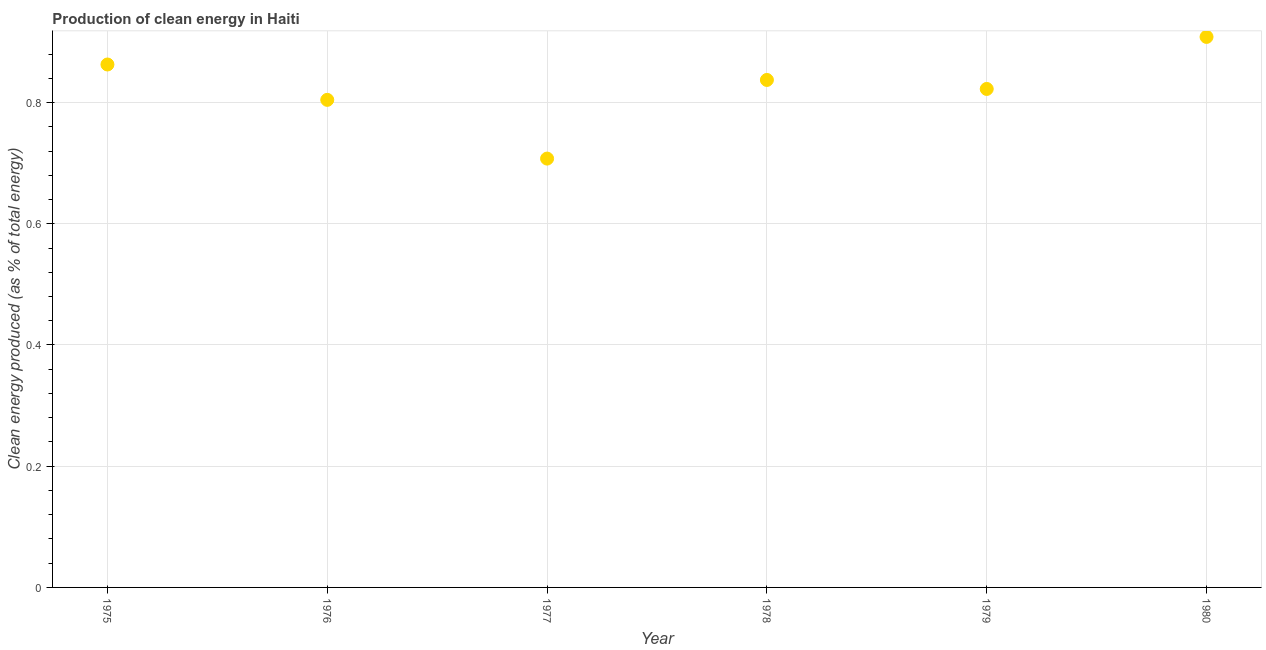What is the production of clean energy in 1977?
Offer a terse response. 0.71. Across all years, what is the maximum production of clean energy?
Offer a very short reply. 0.91. Across all years, what is the minimum production of clean energy?
Ensure brevity in your answer.  0.71. In which year was the production of clean energy minimum?
Your response must be concise. 1977. What is the sum of the production of clean energy?
Provide a short and direct response. 4.94. What is the difference between the production of clean energy in 1978 and 1980?
Ensure brevity in your answer.  -0.07. What is the average production of clean energy per year?
Ensure brevity in your answer.  0.82. What is the median production of clean energy?
Keep it short and to the point. 0.83. Do a majority of the years between 1980 and 1979 (inclusive) have production of clean energy greater than 0.32 %?
Your answer should be very brief. No. What is the ratio of the production of clean energy in 1978 to that in 1979?
Give a very brief answer. 1.02. Is the production of clean energy in 1975 less than that in 1977?
Make the answer very short. No. What is the difference between the highest and the second highest production of clean energy?
Keep it short and to the point. 0.05. What is the difference between the highest and the lowest production of clean energy?
Offer a very short reply. 0.2. In how many years, is the production of clean energy greater than the average production of clean energy taken over all years?
Give a very brief answer. 3. How many dotlines are there?
Your response must be concise. 1. How many years are there in the graph?
Make the answer very short. 6. What is the difference between two consecutive major ticks on the Y-axis?
Your answer should be very brief. 0.2. Does the graph contain grids?
Provide a succinct answer. Yes. What is the title of the graph?
Offer a terse response. Production of clean energy in Haiti. What is the label or title of the X-axis?
Give a very brief answer. Year. What is the label or title of the Y-axis?
Give a very brief answer. Clean energy produced (as % of total energy). What is the Clean energy produced (as % of total energy) in 1975?
Provide a succinct answer. 0.86. What is the Clean energy produced (as % of total energy) in 1976?
Provide a succinct answer. 0.8. What is the Clean energy produced (as % of total energy) in 1977?
Offer a very short reply. 0.71. What is the Clean energy produced (as % of total energy) in 1978?
Offer a terse response. 0.84. What is the Clean energy produced (as % of total energy) in 1979?
Provide a succinct answer. 0.82. What is the Clean energy produced (as % of total energy) in 1980?
Keep it short and to the point. 0.91. What is the difference between the Clean energy produced (as % of total energy) in 1975 and 1976?
Your answer should be compact. 0.06. What is the difference between the Clean energy produced (as % of total energy) in 1975 and 1977?
Ensure brevity in your answer.  0.16. What is the difference between the Clean energy produced (as % of total energy) in 1975 and 1978?
Offer a terse response. 0.03. What is the difference between the Clean energy produced (as % of total energy) in 1975 and 1979?
Give a very brief answer. 0.04. What is the difference between the Clean energy produced (as % of total energy) in 1975 and 1980?
Keep it short and to the point. -0.05. What is the difference between the Clean energy produced (as % of total energy) in 1976 and 1977?
Your answer should be compact. 0.1. What is the difference between the Clean energy produced (as % of total energy) in 1976 and 1978?
Provide a short and direct response. -0.03. What is the difference between the Clean energy produced (as % of total energy) in 1976 and 1979?
Provide a succinct answer. -0.02. What is the difference between the Clean energy produced (as % of total energy) in 1976 and 1980?
Keep it short and to the point. -0.1. What is the difference between the Clean energy produced (as % of total energy) in 1977 and 1978?
Your answer should be compact. -0.13. What is the difference between the Clean energy produced (as % of total energy) in 1977 and 1979?
Your answer should be very brief. -0.11. What is the difference between the Clean energy produced (as % of total energy) in 1977 and 1980?
Provide a short and direct response. -0.2. What is the difference between the Clean energy produced (as % of total energy) in 1978 and 1979?
Your answer should be very brief. 0.01. What is the difference between the Clean energy produced (as % of total energy) in 1978 and 1980?
Provide a short and direct response. -0.07. What is the difference between the Clean energy produced (as % of total energy) in 1979 and 1980?
Provide a succinct answer. -0.09. What is the ratio of the Clean energy produced (as % of total energy) in 1975 to that in 1976?
Your answer should be compact. 1.07. What is the ratio of the Clean energy produced (as % of total energy) in 1975 to that in 1977?
Provide a succinct answer. 1.22. What is the ratio of the Clean energy produced (as % of total energy) in 1975 to that in 1979?
Provide a succinct answer. 1.05. What is the ratio of the Clean energy produced (as % of total energy) in 1976 to that in 1977?
Keep it short and to the point. 1.14. What is the ratio of the Clean energy produced (as % of total energy) in 1976 to that in 1980?
Offer a very short reply. 0.89. What is the ratio of the Clean energy produced (as % of total energy) in 1977 to that in 1978?
Make the answer very short. 0.84. What is the ratio of the Clean energy produced (as % of total energy) in 1977 to that in 1979?
Ensure brevity in your answer.  0.86. What is the ratio of the Clean energy produced (as % of total energy) in 1977 to that in 1980?
Offer a terse response. 0.78. What is the ratio of the Clean energy produced (as % of total energy) in 1978 to that in 1980?
Ensure brevity in your answer.  0.92. What is the ratio of the Clean energy produced (as % of total energy) in 1979 to that in 1980?
Provide a succinct answer. 0.91. 